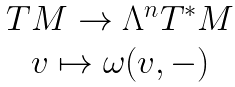<formula> <loc_0><loc_0><loc_500><loc_500>\begin{array} { c } T M \to \Lambda ^ { n } T ^ { \ast } M \\ v \mapsto \omega ( v , - ) \end{array}</formula> 